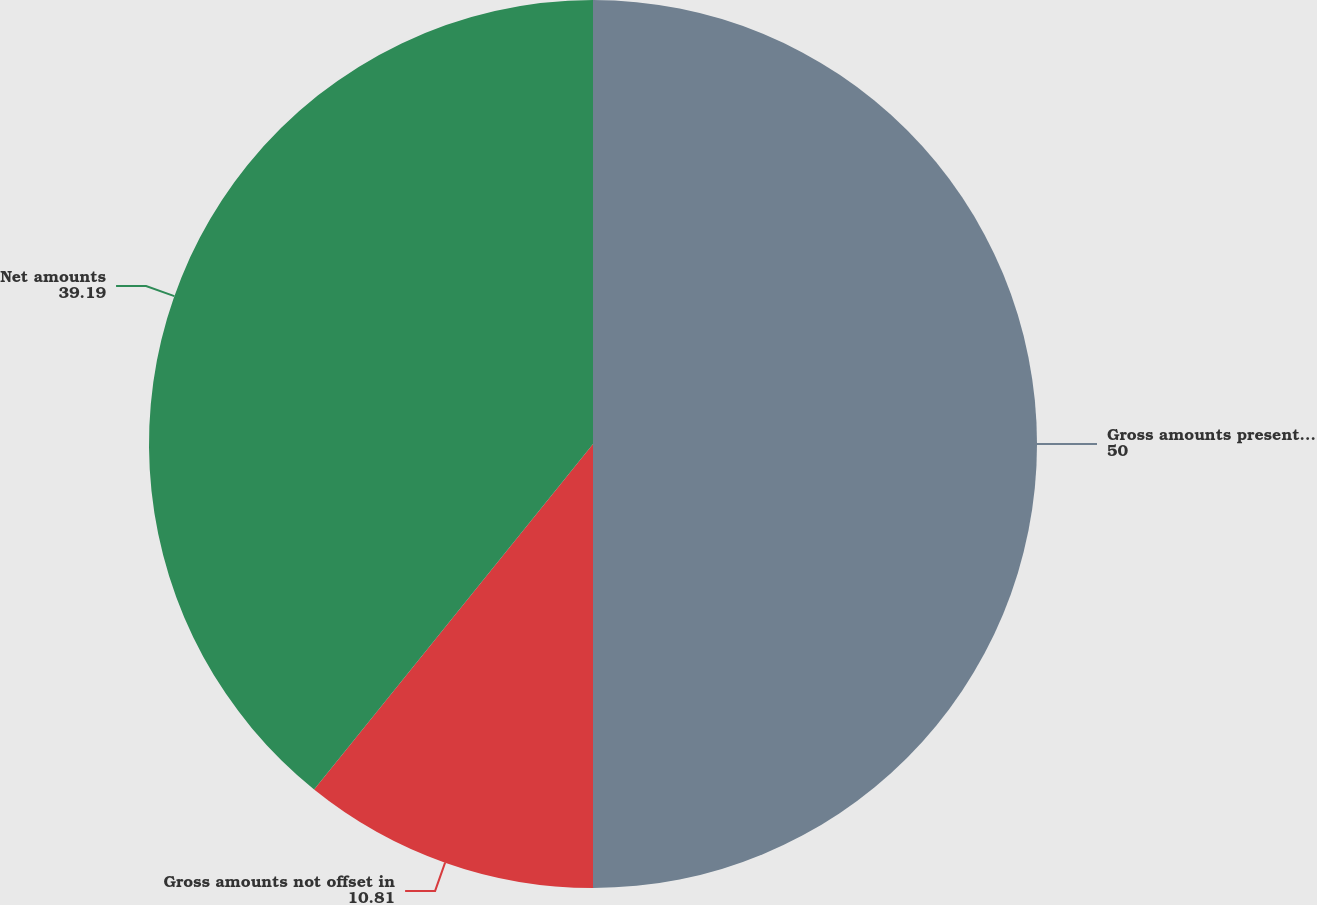<chart> <loc_0><loc_0><loc_500><loc_500><pie_chart><fcel>Gross amounts presented in the<fcel>Gross amounts not offset in<fcel>Net amounts<nl><fcel>50.0%<fcel>10.81%<fcel>39.19%<nl></chart> 